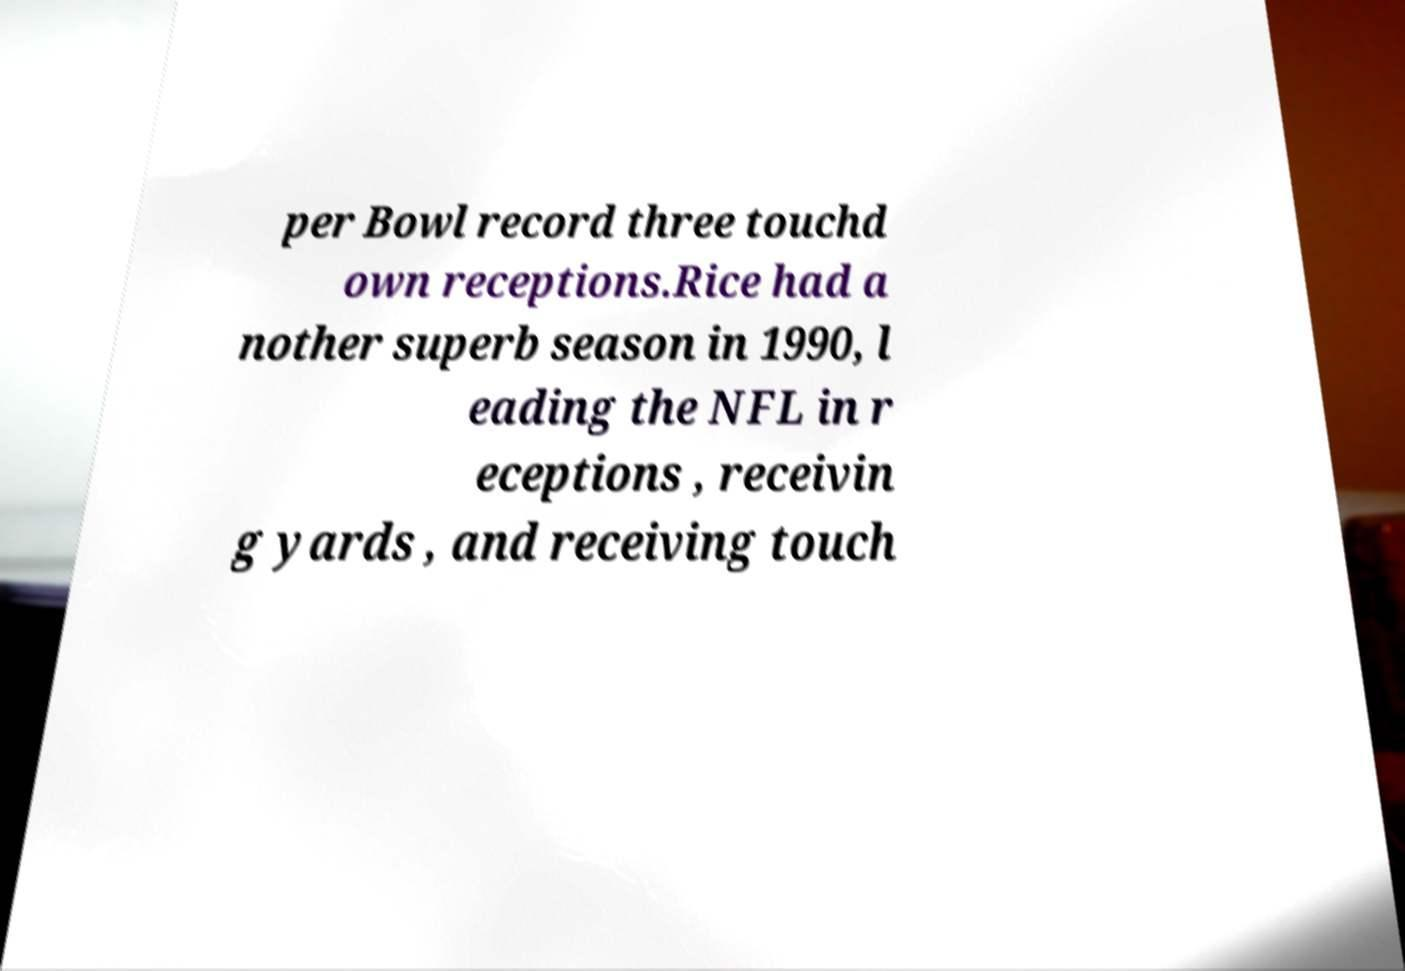I need the written content from this picture converted into text. Can you do that? per Bowl record three touchd own receptions.Rice had a nother superb season in 1990, l eading the NFL in r eceptions , receivin g yards , and receiving touch 